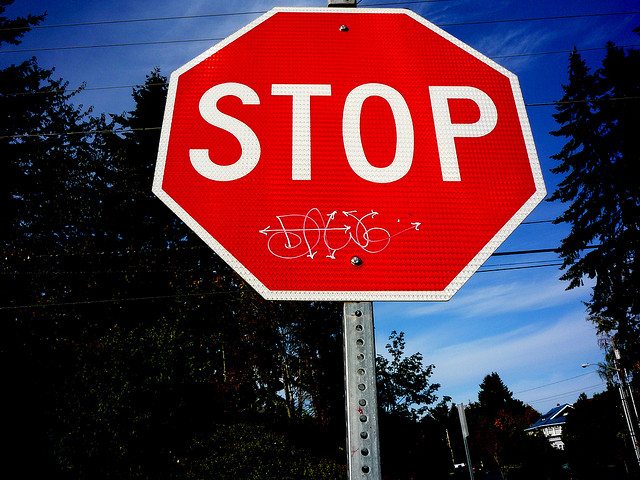Please identify all text content in this image. STOP 